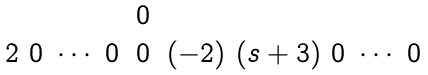Convert formula to latex. <formula><loc_0><loc_0><loc_500><loc_500>\begin{matrix} & 0 & \\ 2 \ 0 \ \cdots \ 0 & 0 & ( - 2 ) \ ( s + 3 ) \ 0 \ \cdots \ 0 \end{matrix}</formula> 